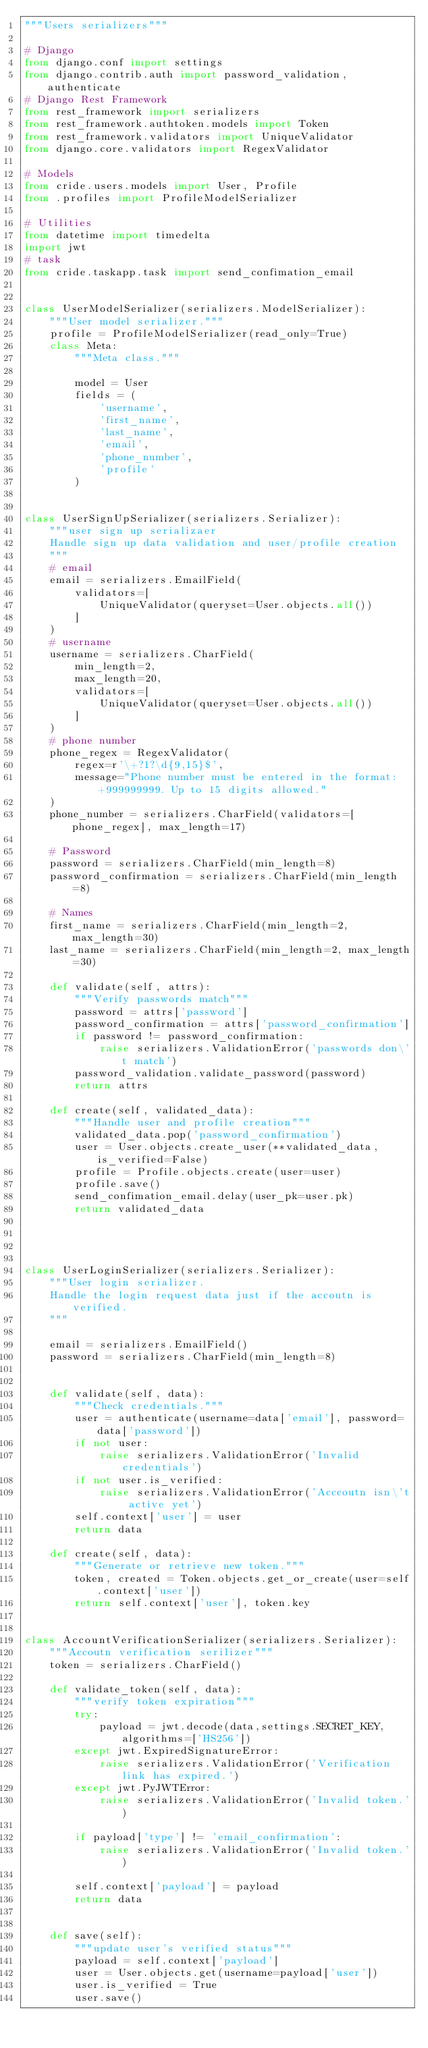<code> <loc_0><loc_0><loc_500><loc_500><_Python_>"""Users serializers"""

# Django
from django.conf import settings
from django.contrib.auth import password_validation,authenticate
# Django Rest Framework
from rest_framework import serializers
from rest_framework.authtoken.models import Token
from rest_framework.validators import UniqueValidator
from django.core.validators import RegexValidator

# Models
from cride.users.models import User, Profile
from .profiles import ProfileModelSerializer

# Utilities
from datetime import timedelta
import jwt
# task
from cride.taskapp.task import send_confimation_email


class UserModelSerializer(serializers.ModelSerializer):
    """User model serializer."""
    profile = ProfileModelSerializer(read_only=True)
    class Meta:
        """Meta class."""

        model = User
        fields = (
            'username',
            'first_name',
            'last_name',
            'email',
            'phone_number',
            'profile'
        )


class UserSignUpSerializer(serializers.Serializer):
    """user sign up serializaer
    Handle sign up data validation and user/profile creation
    """
    # email
    email = serializers.EmailField(
        validators=[
            UniqueValidator(queryset=User.objects.all())
        ]
    )
    # username
    username = serializers.CharField(
        min_length=2,
        max_length=20,
        validators=[
            UniqueValidator(queryset=User.objects.all())
        ]
    )
    # phone number
    phone_regex = RegexValidator(
        regex=r'\+?1?\d{9,15}$',
        message="Phone number must be entered in the format: +999999999. Up to 15 digits allowed."
    )
    phone_number = serializers.CharField(validators=[phone_regex], max_length=17)

    # Password
    password = serializers.CharField(min_length=8)
    password_confirmation = serializers.CharField(min_length=8)

    # Names
    first_name = serializers.CharField(min_length=2, max_length=30)
    last_name = serializers.CharField(min_length=2, max_length=30)

    def validate(self, attrs):
        """Verify passwords match"""
        password = attrs['password']
        password_confirmation = attrs['password_confirmation']
        if password != password_confirmation:
            raise serializers.ValidationError('passwords don\'t match')
        password_validation.validate_password(password)
        return attrs

    def create(self, validated_data):
        """Handle user and profile creation"""
        validated_data.pop('password_confirmation')
        user = User.objects.create_user(**validated_data, is_verified=False)
        profile = Profile.objects.create(user=user)
        profile.save()
        send_confimation_email.delay(user_pk=user.pk)
        return validated_data




class UserLoginSerializer(serializers.Serializer):
    """User login serializer.
    Handle the login request data just if the accoutn is verified.
    """

    email = serializers.EmailField()
    password = serializers.CharField(min_length=8)


    def validate(self, data):
        """Check credentials."""
        user = authenticate(username=data['email'], password=data['password'])
        if not user:
            raise serializers.ValidationError('Invalid credentials')
        if not user.is_verified:
            raise serializers.ValidationError('Acccoutn isn\'t active yet')
        self.context['user'] = user
        return data

    def create(self, data):
        """Generate or retrieve new token."""
        token, created = Token.objects.get_or_create(user=self.context['user'])
        return self.context['user'], token.key


class AccountVerificationSerializer(serializers.Serializer):
    """Accoutn verification serilizer"""
    token = serializers.CharField()

    def validate_token(self, data):
        """verify token expiration"""
        try:
            payload = jwt.decode(data,settings.SECRET_KEY, algorithms=['HS256'])
        except jwt.ExpiredSignatureError:
            raise serializers.ValidationError('Verification link has expired.')
        except jwt.PyJWTError:
            raise serializers.ValidationError('Invalid token.')

        if payload['type'] != 'email_confirmation':
            raise serializers.ValidationError('Invalid token.')

        self.context['payload'] = payload
        return data


    def save(self):
        """update user's verified status"""
        payload = self.context['payload']
        user = User.objects.get(username=payload['user'])
        user.is_verified = True
        user.save()
</code> 